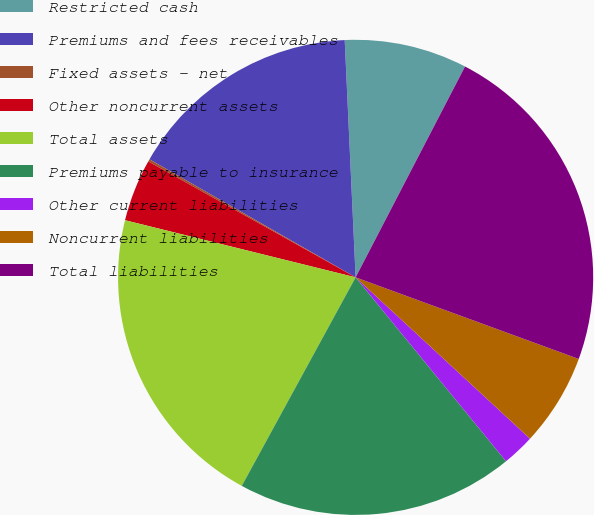Convert chart. <chart><loc_0><loc_0><loc_500><loc_500><pie_chart><fcel>Restricted cash<fcel>Premiums and fees receivables<fcel>Fixed assets - net<fcel>Other noncurrent assets<fcel>Total assets<fcel>Premiums payable to insurance<fcel>Other current liabilities<fcel>Noncurrent liabilities<fcel>Total liabilities<nl><fcel>8.35%<fcel>15.99%<fcel>0.16%<fcel>4.25%<fcel>20.91%<fcel>18.86%<fcel>2.21%<fcel>6.3%<fcel>22.96%<nl></chart> 